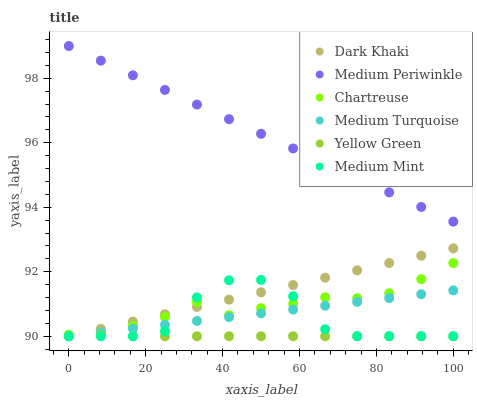Does Yellow Green have the minimum area under the curve?
Answer yes or no. Yes. Does Medium Periwinkle have the maximum area under the curve?
Answer yes or no. Yes. Does Medium Periwinkle have the minimum area under the curve?
Answer yes or no. No. Does Yellow Green have the maximum area under the curve?
Answer yes or no. No. Is Medium Turquoise the smoothest?
Answer yes or no. Yes. Is Medium Mint the roughest?
Answer yes or no. Yes. Is Yellow Green the smoothest?
Answer yes or no. No. Is Yellow Green the roughest?
Answer yes or no. No. Does Medium Mint have the lowest value?
Answer yes or no. Yes. Does Medium Periwinkle have the lowest value?
Answer yes or no. No. Does Medium Periwinkle have the highest value?
Answer yes or no. Yes. Does Yellow Green have the highest value?
Answer yes or no. No. Is Chartreuse less than Medium Periwinkle?
Answer yes or no. Yes. Is Chartreuse greater than Yellow Green?
Answer yes or no. Yes. Does Medium Mint intersect Dark Khaki?
Answer yes or no. Yes. Is Medium Mint less than Dark Khaki?
Answer yes or no. No. Is Medium Mint greater than Dark Khaki?
Answer yes or no. No. Does Chartreuse intersect Medium Periwinkle?
Answer yes or no. No. 